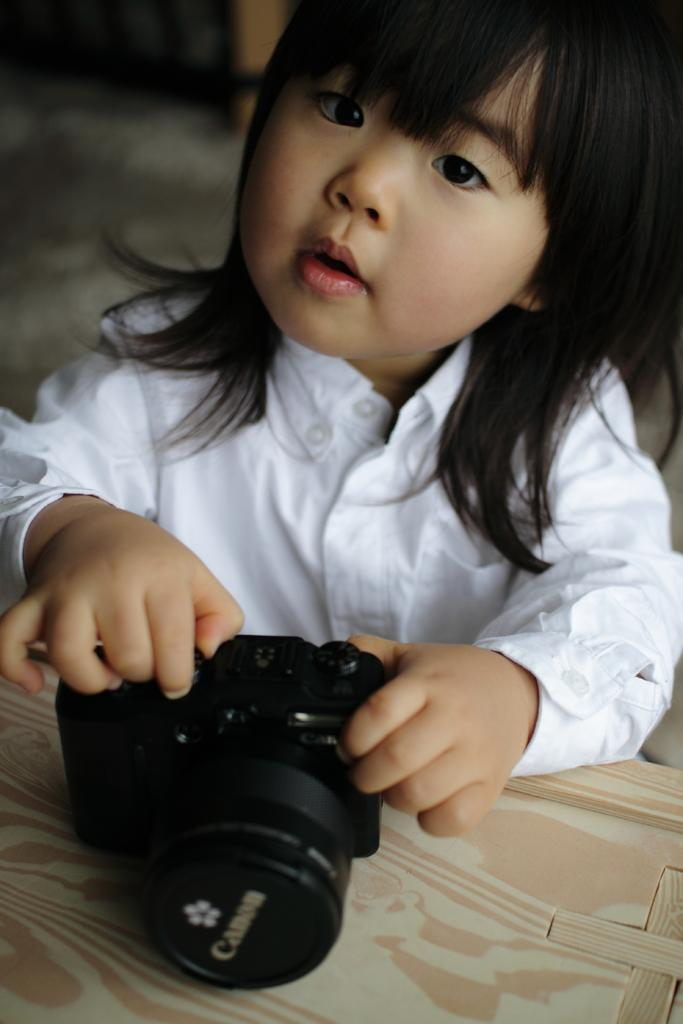Who is the main subject in the image? There is a girl in the image. What is the girl holding in the image? The girl is holding a camera. Where is the camera placed in the image? The camera is placed on a table. What is the girl wearing in the image? The girl is wearing a white shirt. What type of spy equipment can be seen in the image? There is no spy equipment present in the image; it features a girl holding a camera. What type of industry is depicted in the image? There is no industry depicted in the image; it features a girl holding a camera. 